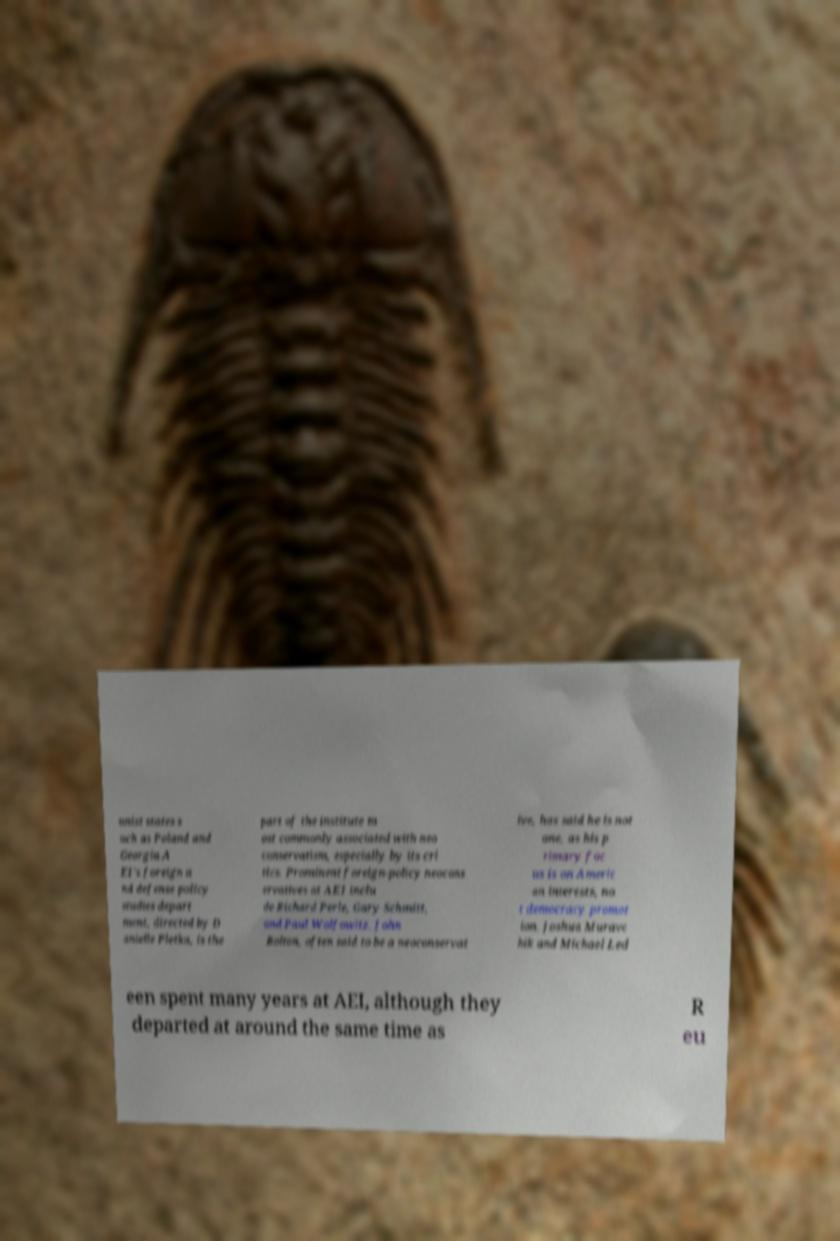Could you assist in decoding the text presented in this image and type it out clearly? unist states s uch as Poland and Georgia.A EI's foreign a nd defense policy studies depart ment, directed by D anielle Pletka, is the part of the institute m ost commonly associated with neo conservatism, especially by its cri tics. Prominent foreign-policy neocons ervatives at AEI inclu de Richard Perle, Gary Schmitt, and Paul Wolfowitz. John Bolton, often said to be a neoconservat ive, has said he is not one, as his p rimary foc us is on Americ an interests, no t democracy promot ion. Joshua Muravc hik and Michael Led een spent many years at AEI, although they departed at around the same time as R eu 